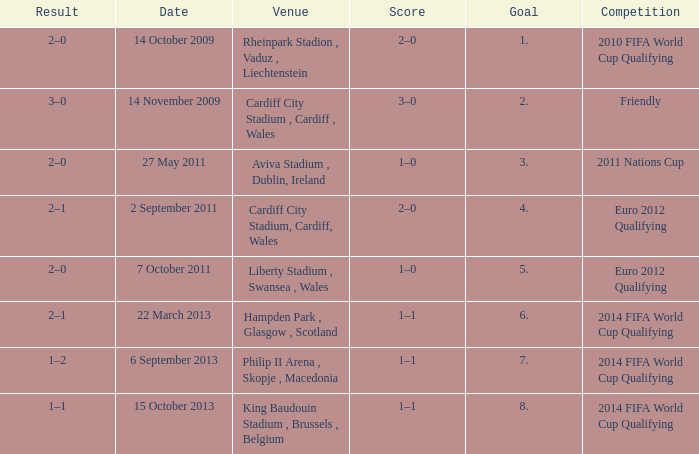Parse the full table. {'header': ['Result', 'Date', 'Venue', 'Score', 'Goal', 'Competition'], 'rows': [['2–0', '14 October 2009', 'Rheinpark Stadion , Vaduz , Liechtenstein', '2–0', '1.', '2010 FIFA World Cup Qualifying'], ['3–0', '14 November 2009', 'Cardiff City Stadium , Cardiff , Wales', '3–0', '2.', 'Friendly'], ['2–0', '27 May 2011', 'Aviva Stadium , Dublin, Ireland', '1–0', '3.', '2011 Nations Cup'], ['2–1', '2 September 2011', 'Cardiff City Stadium, Cardiff, Wales', '2–0', '4.', 'Euro 2012 Qualifying'], ['2–0', '7 October 2011', 'Liberty Stadium , Swansea , Wales', '1–0', '5.', 'Euro 2012 Qualifying'], ['2–1', '22 March 2013', 'Hampden Park , Glasgow , Scotland', '1–1', '6.', '2014 FIFA World Cup Qualifying'], ['1–2', '6 September 2013', 'Philip II Arena , Skopje , Macedonia', '1–1', '7.', '2014 FIFA World Cup Qualifying'], ['1–1', '15 October 2013', 'King Baudouin Stadium , Brussels , Belgium', '1–1', '8.', '2014 FIFA World Cup Qualifying']]} What is the Venue for Goal number 1? Rheinpark Stadion , Vaduz , Liechtenstein. 